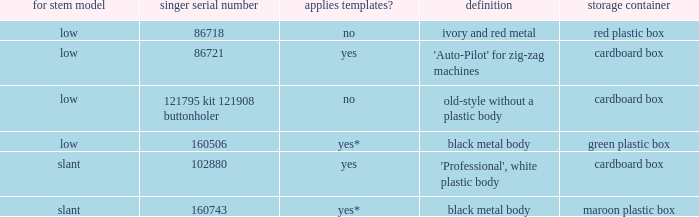What's the description of the buttonholer whose singer part number is 121795 kit 121908 buttonholer? Old-style without a plastic body. 